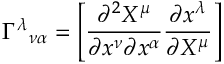<formula> <loc_0><loc_0><loc_500><loc_500>\Gamma ^ { \lambda _ { \nu \alpha } = \left [ { \frac { \partial ^ { 2 } X ^ { \mu } } { \partial x ^ { \nu } \partial x ^ { \alpha } } } { \frac { \partial x ^ { \lambda } } { \partial X ^ { \mu } } } \right ]</formula> 